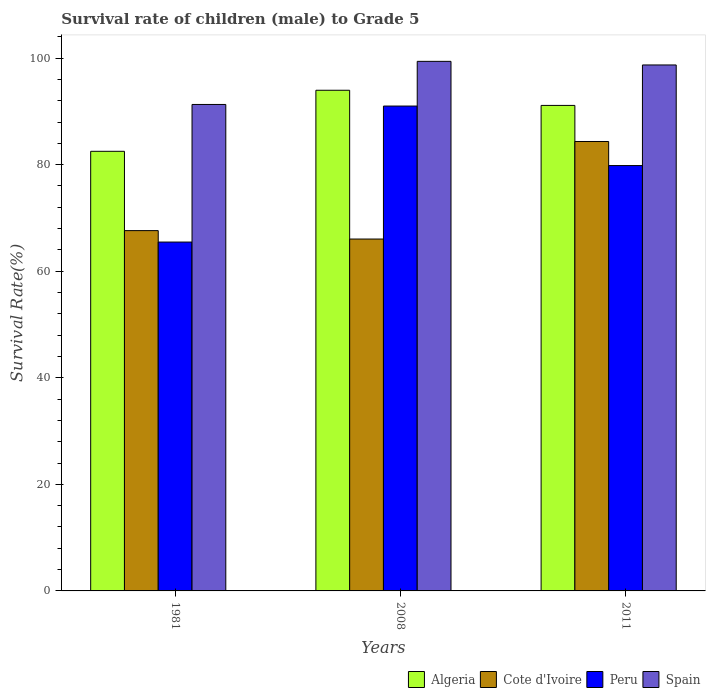How many different coloured bars are there?
Offer a very short reply. 4. How many groups of bars are there?
Your answer should be compact. 3. Are the number of bars on each tick of the X-axis equal?
Your answer should be compact. Yes. What is the label of the 2nd group of bars from the left?
Make the answer very short. 2008. What is the survival rate of male children to grade 5 in Cote d'Ivoire in 2011?
Your answer should be compact. 84.35. Across all years, what is the maximum survival rate of male children to grade 5 in Peru?
Your answer should be very brief. 91. Across all years, what is the minimum survival rate of male children to grade 5 in Algeria?
Offer a terse response. 82.51. What is the total survival rate of male children to grade 5 in Peru in the graph?
Give a very brief answer. 236.3. What is the difference between the survival rate of male children to grade 5 in Algeria in 1981 and that in 2008?
Your answer should be very brief. -11.46. What is the difference between the survival rate of male children to grade 5 in Cote d'Ivoire in 1981 and the survival rate of male children to grade 5 in Algeria in 2008?
Your response must be concise. -26.34. What is the average survival rate of male children to grade 5 in Peru per year?
Provide a short and direct response. 78.77. In the year 2011, what is the difference between the survival rate of male children to grade 5 in Algeria and survival rate of male children to grade 5 in Cote d'Ivoire?
Your response must be concise. 6.77. What is the ratio of the survival rate of male children to grade 5 in Algeria in 2008 to that in 2011?
Keep it short and to the point. 1.03. What is the difference between the highest and the second highest survival rate of male children to grade 5 in Cote d'Ivoire?
Make the answer very short. 16.73. What is the difference between the highest and the lowest survival rate of male children to grade 5 in Spain?
Your response must be concise. 8.09. Is it the case that in every year, the sum of the survival rate of male children to grade 5 in Cote d'Ivoire and survival rate of male children to grade 5 in Spain is greater than the sum of survival rate of male children to grade 5 in Algeria and survival rate of male children to grade 5 in Peru?
Your response must be concise. Yes. What does the 4th bar from the left in 2011 represents?
Your answer should be very brief. Spain. What does the 4th bar from the right in 1981 represents?
Offer a terse response. Algeria. Is it the case that in every year, the sum of the survival rate of male children to grade 5 in Spain and survival rate of male children to grade 5 in Algeria is greater than the survival rate of male children to grade 5 in Peru?
Your response must be concise. Yes. How many bars are there?
Keep it short and to the point. 12. What is the difference between two consecutive major ticks on the Y-axis?
Give a very brief answer. 20. Are the values on the major ticks of Y-axis written in scientific E-notation?
Give a very brief answer. No. Where does the legend appear in the graph?
Give a very brief answer. Bottom right. How many legend labels are there?
Offer a terse response. 4. How are the legend labels stacked?
Provide a succinct answer. Horizontal. What is the title of the graph?
Keep it short and to the point. Survival rate of children (male) to Grade 5. What is the label or title of the Y-axis?
Give a very brief answer. Survival Rate(%). What is the Survival Rate(%) of Algeria in 1981?
Give a very brief answer. 82.51. What is the Survival Rate(%) in Cote d'Ivoire in 1981?
Make the answer very short. 67.62. What is the Survival Rate(%) of Peru in 1981?
Ensure brevity in your answer.  65.47. What is the Survival Rate(%) of Spain in 1981?
Offer a very short reply. 91.3. What is the Survival Rate(%) in Algeria in 2008?
Provide a short and direct response. 93.96. What is the Survival Rate(%) in Cote d'Ivoire in 2008?
Ensure brevity in your answer.  66.04. What is the Survival Rate(%) of Peru in 2008?
Provide a succinct answer. 91. What is the Survival Rate(%) of Spain in 2008?
Keep it short and to the point. 99.39. What is the Survival Rate(%) in Algeria in 2011?
Offer a very short reply. 91.12. What is the Survival Rate(%) of Cote d'Ivoire in 2011?
Keep it short and to the point. 84.35. What is the Survival Rate(%) of Peru in 2011?
Provide a succinct answer. 79.83. What is the Survival Rate(%) of Spain in 2011?
Make the answer very short. 98.71. Across all years, what is the maximum Survival Rate(%) in Algeria?
Make the answer very short. 93.96. Across all years, what is the maximum Survival Rate(%) of Cote d'Ivoire?
Your answer should be compact. 84.35. Across all years, what is the maximum Survival Rate(%) in Peru?
Provide a short and direct response. 91. Across all years, what is the maximum Survival Rate(%) of Spain?
Keep it short and to the point. 99.39. Across all years, what is the minimum Survival Rate(%) of Algeria?
Make the answer very short. 82.51. Across all years, what is the minimum Survival Rate(%) in Cote d'Ivoire?
Provide a short and direct response. 66.04. Across all years, what is the minimum Survival Rate(%) in Peru?
Offer a very short reply. 65.47. Across all years, what is the minimum Survival Rate(%) of Spain?
Ensure brevity in your answer.  91.3. What is the total Survival Rate(%) in Algeria in the graph?
Your answer should be very brief. 267.59. What is the total Survival Rate(%) of Cote d'Ivoire in the graph?
Make the answer very short. 218.01. What is the total Survival Rate(%) of Peru in the graph?
Ensure brevity in your answer.  236.3. What is the total Survival Rate(%) in Spain in the graph?
Provide a succinct answer. 289.4. What is the difference between the Survival Rate(%) in Algeria in 1981 and that in 2008?
Your response must be concise. -11.46. What is the difference between the Survival Rate(%) in Cote d'Ivoire in 1981 and that in 2008?
Your answer should be very brief. 1.58. What is the difference between the Survival Rate(%) of Peru in 1981 and that in 2008?
Make the answer very short. -25.52. What is the difference between the Survival Rate(%) in Spain in 1981 and that in 2008?
Offer a very short reply. -8.09. What is the difference between the Survival Rate(%) in Algeria in 1981 and that in 2011?
Make the answer very short. -8.61. What is the difference between the Survival Rate(%) of Cote d'Ivoire in 1981 and that in 2011?
Offer a terse response. -16.73. What is the difference between the Survival Rate(%) in Peru in 1981 and that in 2011?
Provide a succinct answer. -14.36. What is the difference between the Survival Rate(%) of Spain in 1981 and that in 2011?
Provide a succinct answer. -7.41. What is the difference between the Survival Rate(%) in Algeria in 2008 and that in 2011?
Offer a very short reply. 2.85. What is the difference between the Survival Rate(%) of Cote d'Ivoire in 2008 and that in 2011?
Give a very brief answer. -18.31. What is the difference between the Survival Rate(%) of Peru in 2008 and that in 2011?
Keep it short and to the point. 11.17. What is the difference between the Survival Rate(%) of Spain in 2008 and that in 2011?
Provide a short and direct response. 0.68. What is the difference between the Survival Rate(%) in Algeria in 1981 and the Survival Rate(%) in Cote d'Ivoire in 2008?
Your response must be concise. 16.46. What is the difference between the Survival Rate(%) in Algeria in 1981 and the Survival Rate(%) in Peru in 2008?
Provide a succinct answer. -8.49. What is the difference between the Survival Rate(%) in Algeria in 1981 and the Survival Rate(%) in Spain in 2008?
Your response must be concise. -16.88. What is the difference between the Survival Rate(%) in Cote d'Ivoire in 1981 and the Survival Rate(%) in Peru in 2008?
Provide a short and direct response. -23.38. What is the difference between the Survival Rate(%) in Cote d'Ivoire in 1981 and the Survival Rate(%) in Spain in 2008?
Your answer should be very brief. -31.77. What is the difference between the Survival Rate(%) of Peru in 1981 and the Survival Rate(%) of Spain in 2008?
Make the answer very short. -33.92. What is the difference between the Survival Rate(%) of Algeria in 1981 and the Survival Rate(%) of Cote d'Ivoire in 2011?
Offer a very short reply. -1.84. What is the difference between the Survival Rate(%) of Algeria in 1981 and the Survival Rate(%) of Peru in 2011?
Keep it short and to the point. 2.68. What is the difference between the Survival Rate(%) of Algeria in 1981 and the Survival Rate(%) of Spain in 2011?
Provide a succinct answer. -16.21. What is the difference between the Survival Rate(%) in Cote d'Ivoire in 1981 and the Survival Rate(%) in Peru in 2011?
Your answer should be very brief. -12.21. What is the difference between the Survival Rate(%) of Cote d'Ivoire in 1981 and the Survival Rate(%) of Spain in 2011?
Your answer should be compact. -31.09. What is the difference between the Survival Rate(%) of Peru in 1981 and the Survival Rate(%) of Spain in 2011?
Offer a terse response. -33.24. What is the difference between the Survival Rate(%) of Algeria in 2008 and the Survival Rate(%) of Cote d'Ivoire in 2011?
Keep it short and to the point. 9.62. What is the difference between the Survival Rate(%) in Algeria in 2008 and the Survival Rate(%) in Peru in 2011?
Offer a terse response. 14.13. What is the difference between the Survival Rate(%) in Algeria in 2008 and the Survival Rate(%) in Spain in 2011?
Your answer should be very brief. -4.75. What is the difference between the Survival Rate(%) in Cote d'Ivoire in 2008 and the Survival Rate(%) in Peru in 2011?
Provide a succinct answer. -13.79. What is the difference between the Survival Rate(%) of Cote d'Ivoire in 2008 and the Survival Rate(%) of Spain in 2011?
Ensure brevity in your answer.  -32.67. What is the difference between the Survival Rate(%) in Peru in 2008 and the Survival Rate(%) in Spain in 2011?
Offer a terse response. -7.71. What is the average Survival Rate(%) in Algeria per year?
Provide a succinct answer. 89.2. What is the average Survival Rate(%) of Cote d'Ivoire per year?
Offer a terse response. 72.67. What is the average Survival Rate(%) of Peru per year?
Give a very brief answer. 78.77. What is the average Survival Rate(%) of Spain per year?
Ensure brevity in your answer.  96.47. In the year 1981, what is the difference between the Survival Rate(%) of Algeria and Survival Rate(%) of Cote d'Ivoire?
Make the answer very short. 14.88. In the year 1981, what is the difference between the Survival Rate(%) in Algeria and Survival Rate(%) in Peru?
Offer a very short reply. 17.03. In the year 1981, what is the difference between the Survival Rate(%) of Algeria and Survival Rate(%) of Spain?
Your response must be concise. -8.79. In the year 1981, what is the difference between the Survival Rate(%) of Cote d'Ivoire and Survival Rate(%) of Peru?
Offer a very short reply. 2.15. In the year 1981, what is the difference between the Survival Rate(%) in Cote d'Ivoire and Survival Rate(%) in Spain?
Make the answer very short. -23.68. In the year 1981, what is the difference between the Survival Rate(%) in Peru and Survival Rate(%) in Spain?
Ensure brevity in your answer.  -25.83. In the year 2008, what is the difference between the Survival Rate(%) in Algeria and Survival Rate(%) in Cote d'Ivoire?
Offer a very short reply. 27.92. In the year 2008, what is the difference between the Survival Rate(%) of Algeria and Survival Rate(%) of Peru?
Keep it short and to the point. 2.97. In the year 2008, what is the difference between the Survival Rate(%) in Algeria and Survival Rate(%) in Spain?
Offer a very short reply. -5.42. In the year 2008, what is the difference between the Survival Rate(%) in Cote d'Ivoire and Survival Rate(%) in Peru?
Ensure brevity in your answer.  -24.96. In the year 2008, what is the difference between the Survival Rate(%) in Cote d'Ivoire and Survival Rate(%) in Spain?
Make the answer very short. -33.35. In the year 2008, what is the difference between the Survival Rate(%) of Peru and Survival Rate(%) of Spain?
Give a very brief answer. -8.39. In the year 2011, what is the difference between the Survival Rate(%) in Algeria and Survival Rate(%) in Cote d'Ivoire?
Make the answer very short. 6.77. In the year 2011, what is the difference between the Survival Rate(%) in Algeria and Survival Rate(%) in Peru?
Make the answer very short. 11.29. In the year 2011, what is the difference between the Survival Rate(%) of Algeria and Survival Rate(%) of Spain?
Your answer should be compact. -7.59. In the year 2011, what is the difference between the Survival Rate(%) of Cote d'Ivoire and Survival Rate(%) of Peru?
Ensure brevity in your answer.  4.52. In the year 2011, what is the difference between the Survival Rate(%) of Cote d'Ivoire and Survival Rate(%) of Spain?
Provide a succinct answer. -14.37. In the year 2011, what is the difference between the Survival Rate(%) in Peru and Survival Rate(%) in Spain?
Offer a terse response. -18.88. What is the ratio of the Survival Rate(%) in Algeria in 1981 to that in 2008?
Provide a short and direct response. 0.88. What is the ratio of the Survival Rate(%) of Cote d'Ivoire in 1981 to that in 2008?
Ensure brevity in your answer.  1.02. What is the ratio of the Survival Rate(%) of Peru in 1981 to that in 2008?
Make the answer very short. 0.72. What is the ratio of the Survival Rate(%) in Spain in 1981 to that in 2008?
Give a very brief answer. 0.92. What is the ratio of the Survival Rate(%) in Algeria in 1981 to that in 2011?
Ensure brevity in your answer.  0.91. What is the ratio of the Survival Rate(%) of Cote d'Ivoire in 1981 to that in 2011?
Provide a succinct answer. 0.8. What is the ratio of the Survival Rate(%) of Peru in 1981 to that in 2011?
Provide a short and direct response. 0.82. What is the ratio of the Survival Rate(%) in Spain in 1981 to that in 2011?
Give a very brief answer. 0.92. What is the ratio of the Survival Rate(%) in Algeria in 2008 to that in 2011?
Ensure brevity in your answer.  1.03. What is the ratio of the Survival Rate(%) in Cote d'Ivoire in 2008 to that in 2011?
Give a very brief answer. 0.78. What is the ratio of the Survival Rate(%) of Peru in 2008 to that in 2011?
Your response must be concise. 1.14. What is the ratio of the Survival Rate(%) in Spain in 2008 to that in 2011?
Make the answer very short. 1.01. What is the difference between the highest and the second highest Survival Rate(%) in Algeria?
Your response must be concise. 2.85. What is the difference between the highest and the second highest Survival Rate(%) of Cote d'Ivoire?
Your answer should be compact. 16.73. What is the difference between the highest and the second highest Survival Rate(%) of Peru?
Your response must be concise. 11.17. What is the difference between the highest and the second highest Survival Rate(%) of Spain?
Provide a succinct answer. 0.68. What is the difference between the highest and the lowest Survival Rate(%) in Algeria?
Keep it short and to the point. 11.46. What is the difference between the highest and the lowest Survival Rate(%) in Cote d'Ivoire?
Give a very brief answer. 18.31. What is the difference between the highest and the lowest Survival Rate(%) in Peru?
Provide a succinct answer. 25.52. What is the difference between the highest and the lowest Survival Rate(%) in Spain?
Your response must be concise. 8.09. 